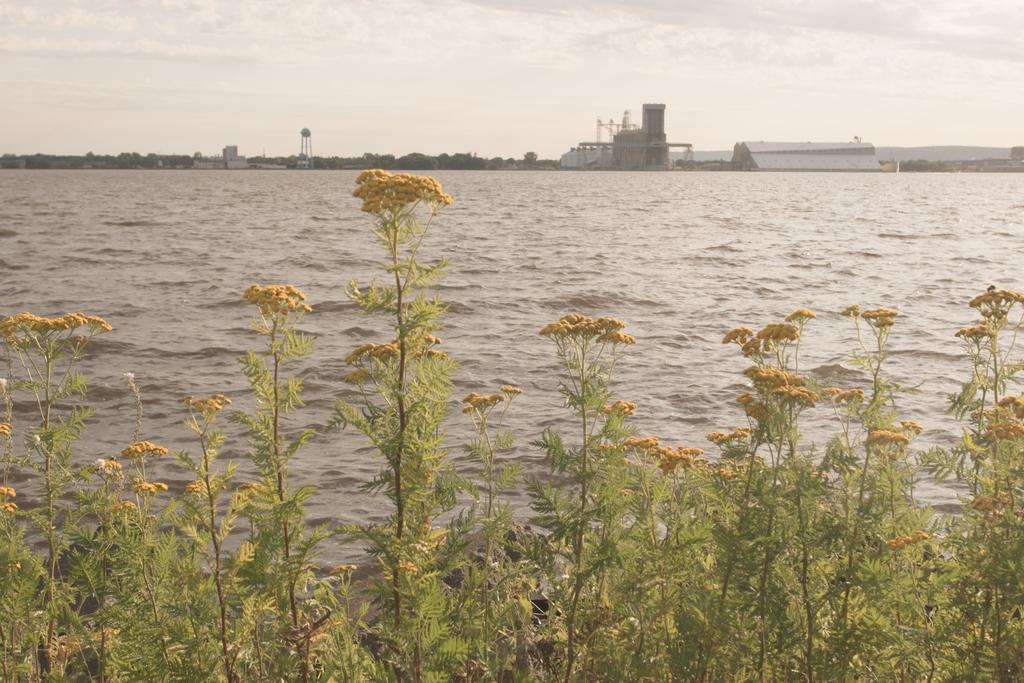What type of living organisms can be seen in the image? Plants can be seen in the image, and they have flowers on them. What is located beside the plants? There is water beside the plants. What can be seen in the background of the image? There are buildings and trees in the background of the image. What type of cloth is draped over the clam in the image? There is no clam or cloth present in the image. 